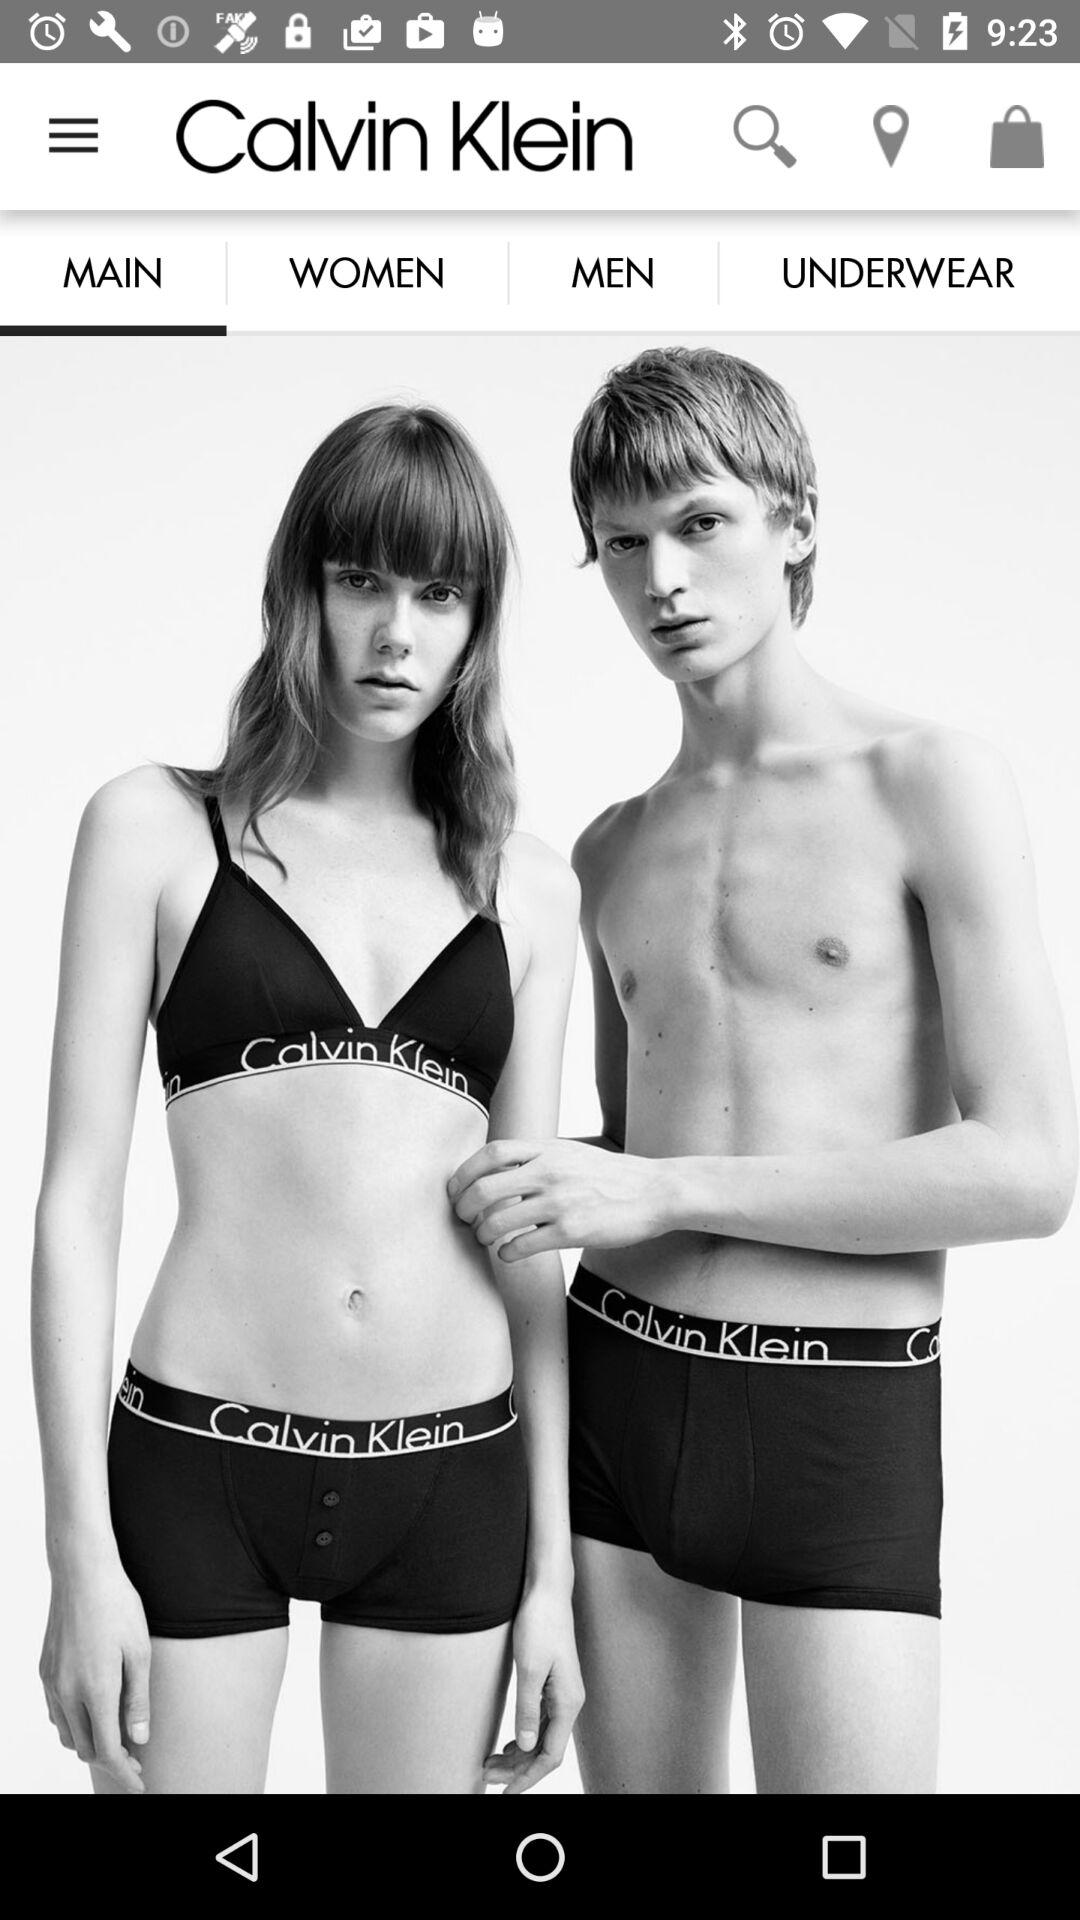What is the application name? The application name is "Calvin Klein". 